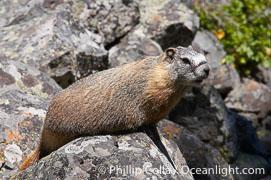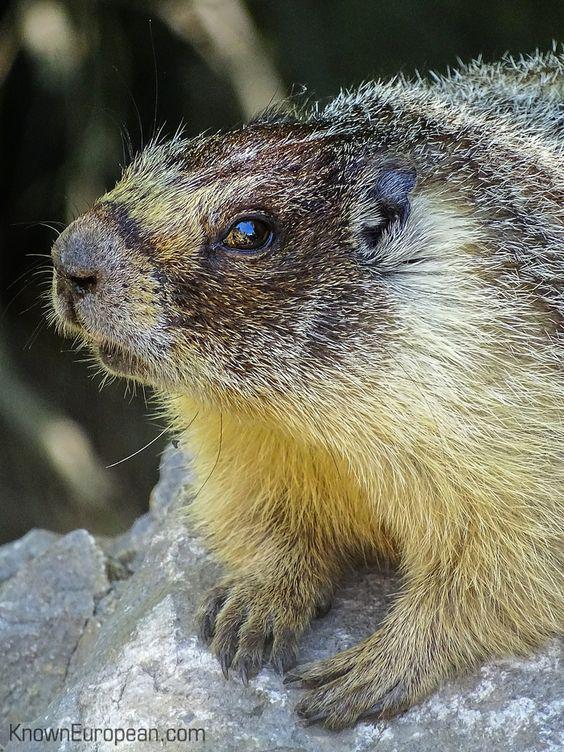The first image is the image on the left, the second image is the image on the right. For the images shown, is this caption "The animal in the image to the left is clearly much more red than it's paired image." true? Answer yes or no. Yes. 